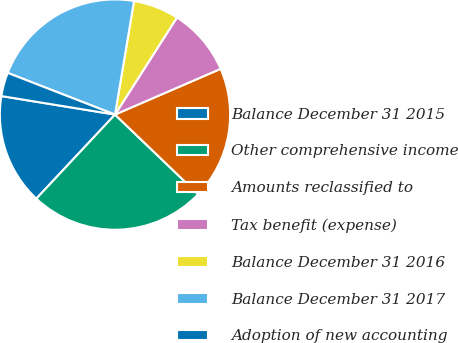Convert chart. <chart><loc_0><loc_0><loc_500><loc_500><pie_chart><fcel>Balance December 31 2015<fcel>Other comprehensive income<fcel>Amounts reclassified to<fcel>Tax benefit (expense)<fcel>Balance December 31 2016<fcel>Balance December 31 2017<fcel>Adoption of new accounting<nl><fcel>15.6%<fcel>24.81%<fcel>18.67%<fcel>9.46%<fcel>6.4%<fcel>21.74%<fcel>3.33%<nl></chart> 